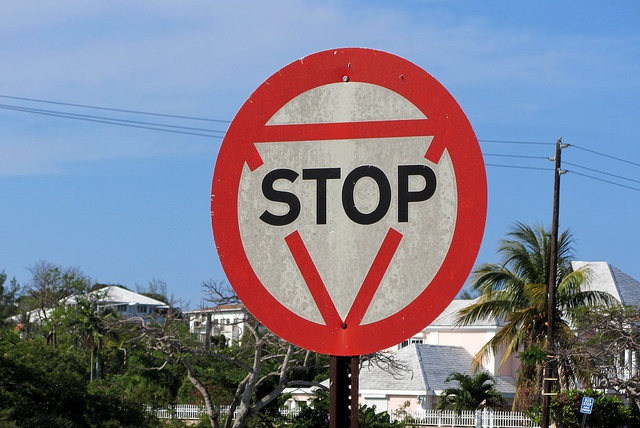Describe the objects in this image and their specific colors. I can see a stop sign in darkgray, brown, black, and lightgray tones in this image. 